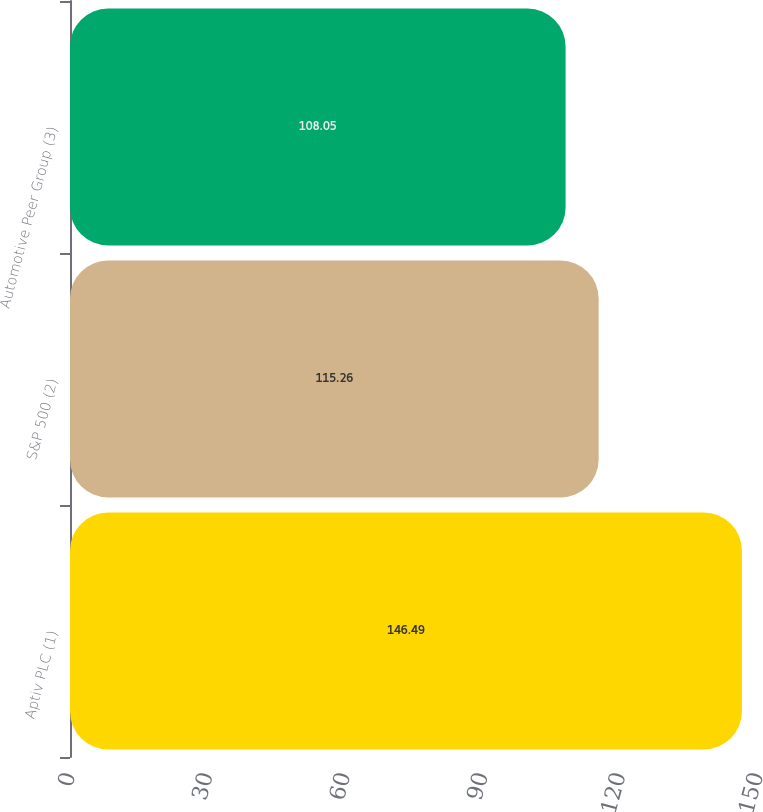<chart> <loc_0><loc_0><loc_500><loc_500><bar_chart><fcel>Aptiv PLC (1)<fcel>S&P 500 (2)<fcel>Automotive Peer Group (3)<nl><fcel>146.49<fcel>115.26<fcel>108.05<nl></chart> 